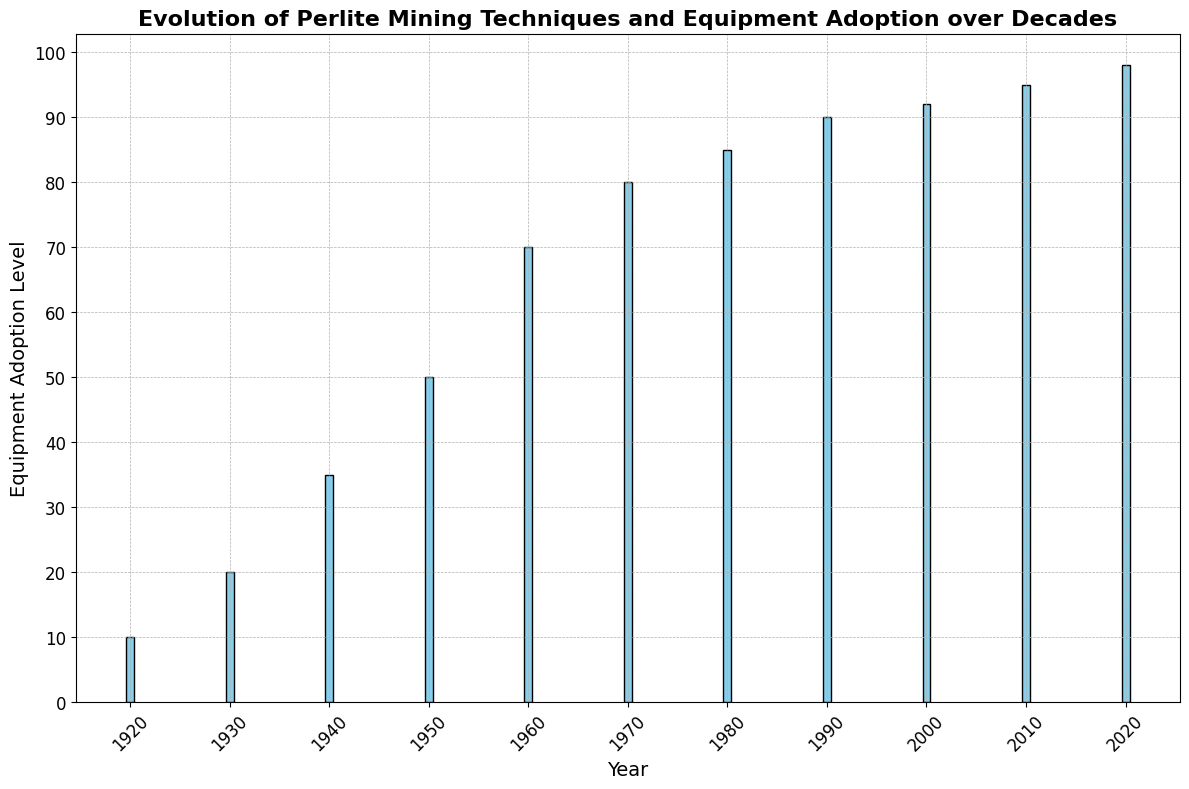What was the Equipment Adoption Level in 1950? Looking at the bar corresponding to the year 1950 in the histogram, the height represents the Equipment Adoption Level. The height is labeled at 50.
Answer: 50 Which year showed the largest jump in Equipment Adoption Level compared to the previous decade? By comparing the heights of consecutive bars, the largest increase is observed between the years 1950 (50) and 1960 (70), which is an increase of 20.
Answer: 1950 to 1960 What is the average Equipment Adoption Level in the decades: 1920, 1930, and 1940? Summing the Equipment Adoption Levels for the decades (10 + 20 + 35) = 65. Dividing 65 by 3 gives an average of approximately 21.67.
Answer: 21.67 Compare the Equipment Adoption Levels between the years 1980 and 2020. Which one is higher and by how much? The bar for 1980 shows an Equipment Adoption Level of 85, and the bar for 2020 shows 98. The difference is 98 - 85 = 13.
Answer: 2020, 13 Which decade shows the adoption of 'Hydraulic Equipment'? The bar for Hydraulic Equipment falls in the decade of 1960.
Answer: 1960 By how much did the Equipment Adoption Level increase between the decades 1940 and 2000? The bar for 1940 is at 35, and the bar for 2000 is at 92. The increase is 92 - 35 = 57.
Answer: 57 What is the median Equipment Adoption Level from the provided years? Listing the values in ascending order: 10, 20, 35, 50, 70, 80, 85, 90, 92, 95, 98. The median value is the middle one which is 80.
Answer: 80 Visually, which bar appears to be the tallest in the histogram? The tallest bar corresponds to the year 2020 indicating the highest Equipment Adoption Level.
Answer: 2020 What trend can you observe in the Equipment Adoption Levels over the decades? By observing the bars from left to right, we see a generally increasing trend in Equipment Adoption Level over the decades without any significant drops.
Answer: Increasing trend 